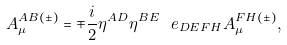<formula> <loc_0><loc_0><loc_500><loc_500>A ^ { A B ( \pm ) } _ { \mu } = \mp \frac { i } { 2 } \eta ^ { A D } \eta ^ { B E } \ e _ { D E F H } A _ { \mu } ^ { F H ( \pm ) } ,</formula> 